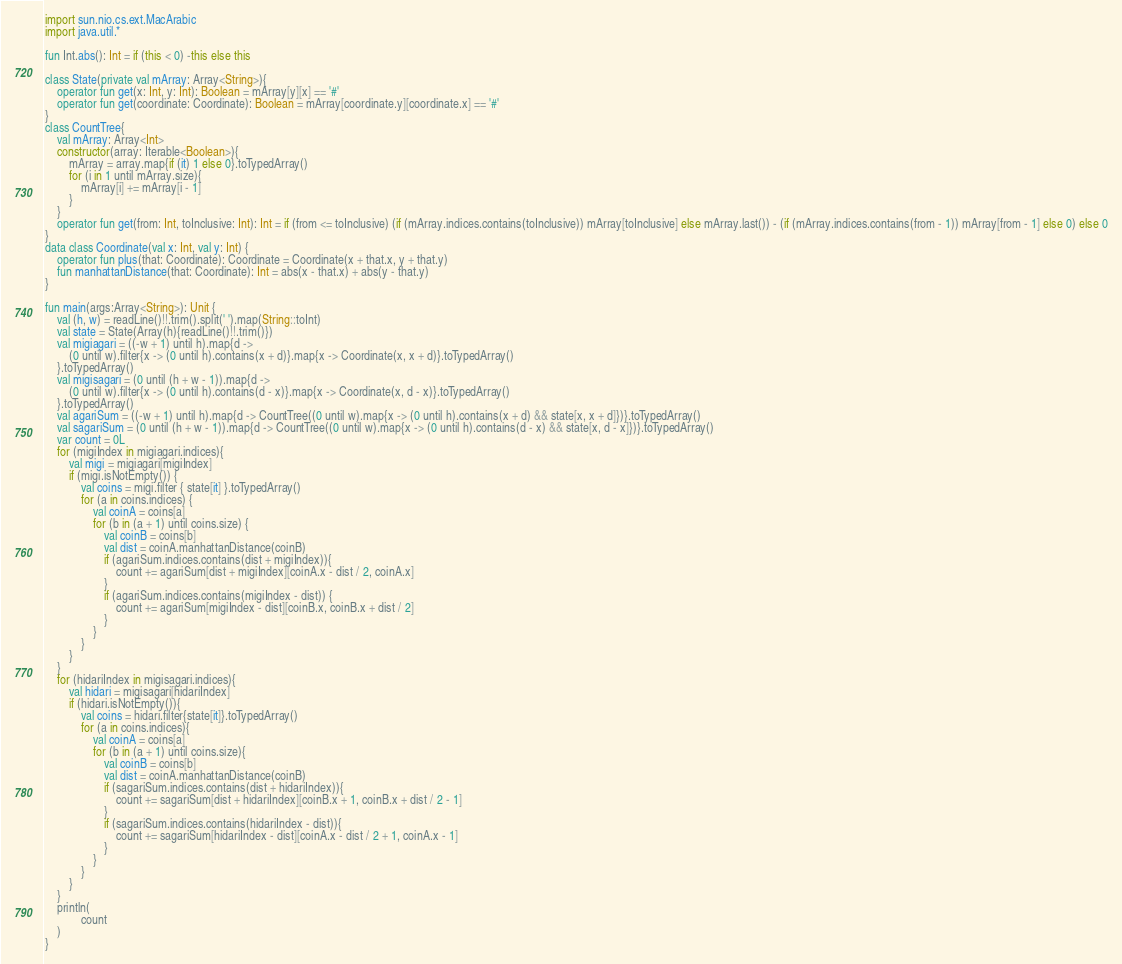<code> <loc_0><loc_0><loc_500><loc_500><_Kotlin_>
import sun.nio.cs.ext.MacArabic
import java.util.*

fun Int.abs(): Int = if (this < 0) -this else this

class State(private val mArray: Array<String>){
    operator fun get(x: Int, y: Int): Boolean = mArray[y][x] == '#'
    operator fun get(coordinate: Coordinate): Boolean = mArray[coordinate.y][coordinate.x] == '#'
}
class CountTree{
    val mArray: Array<Int>
    constructor(array: Iterable<Boolean>){
        mArray = array.map{if (it) 1 else 0}.toTypedArray()
        for (i in 1 until mArray.size){
            mArray[i] += mArray[i - 1]
        }
    }
    operator fun get(from: Int, toInclusive: Int): Int = if (from <= toInclusive) (if (mArray.indices.contains(toInclusive)) mArray[toInclusive] else mArray.last()) - (if (mArray.indices.contains(from - 1)) mArray[from - 1] else 0) else 0
}
data class Coordinate(val x: Int, val y: Int) {
    operator fun plus(that: Coordinate): Coordinate = Coordinate(x + that.x, y + that.y)
    fun manhattanDistance(that: Coordinate): Int = abs(x - that.x) + abs(y - that.y)
}

fun main(args:Array<String>): Unit {
    val (h, w) = readLine()!!.trim().split(' ').map(String::toInt)
    val state = State(Array(h){readLine()!!.trim()})
    val migiagari = ((-w + 1) until h).map{d ->
        (0 until w).filter{x -> (0 until h).contains(x + d)}.map{x -> Coordinate(x, x + d)}.toTypedArray()
    }.toTypedArray()
    val migisagari = (0 until (h + w - 1)).map{d ->
        (0 until w).filter{x -> (0 until h).contains(d - x)}.map{x -> Coordinate(x, d - x)}.toTypedArray()
    }.toTypedArray()
    val agariSum = ((-w + 1) until h).map{d -> CountTree((0 until w).map{x -> (0 until h).contains(x + d) && state[x, x + d]})}.toTypedArray()
    val sagariSum = (0 until (h + w - 1)).map{d -> CountTree((0 until w).map{x -> (0 until h).contains(d - x) && state[x, d - x]})}.toTypedArray()
    var count = 0L
    for (migiIndex in migiagari.indices){
        val migi = migiagari[migiIndex]
        if (migi.isNotEmpty()) {
            val coins = migi.filter { state[it] }.toTypedArray()
            for (a in coins.indices) {
                val coinA = coins[a]
                for (b in (a + 1) until coins.size) {
                    val coinB = coins[b]
                    val dist = coinA.manhattanDistance(coinB)
                    if (agariSum.indices.contains(dist + migiIndex)){
                        count += agariSum[dist + migiIndex][coinA.x - dist / 2, coinA.x]
                    }
                    if (agariSum.indices.contains(migiIndex - dist)) {
                        count += agariSum[migiIndex - dist][coinB.x, coinB.x + dist / 2]
                    }
                }
            }
        }
    }
    for (hidariIndex in migisagari.indices){
        val hidari = migisagari[hidariIndex]
        if (hidari.isNotEmpty()){
            val coins = hidari.filter{state[it]}.toTypedArray()
            for (a in coins.indices){
                val coinA = coins[a]
                for (b in (a + 1) until coins.size){
                    val coinB = coins[b]
                    val dist = coinA.manhattanDistance(coinB)
                    if (sagariSum.indices.contains(dist + hidariIndex)){
                        count += sagariSum[dist + hidariIndex][coinB.x + 1, coinB.x + dist / 2 - 1]
                    }
                    if (sagariSum.indices.contains(hidariIndex - dist)){
                        count += sagariSum[hidariIndex - dist][coinA.x - dist / 2 + 1, coinA.x - 1]
                    }
                }
            }
        }
    }
    println(
            count
    )
}</code> 